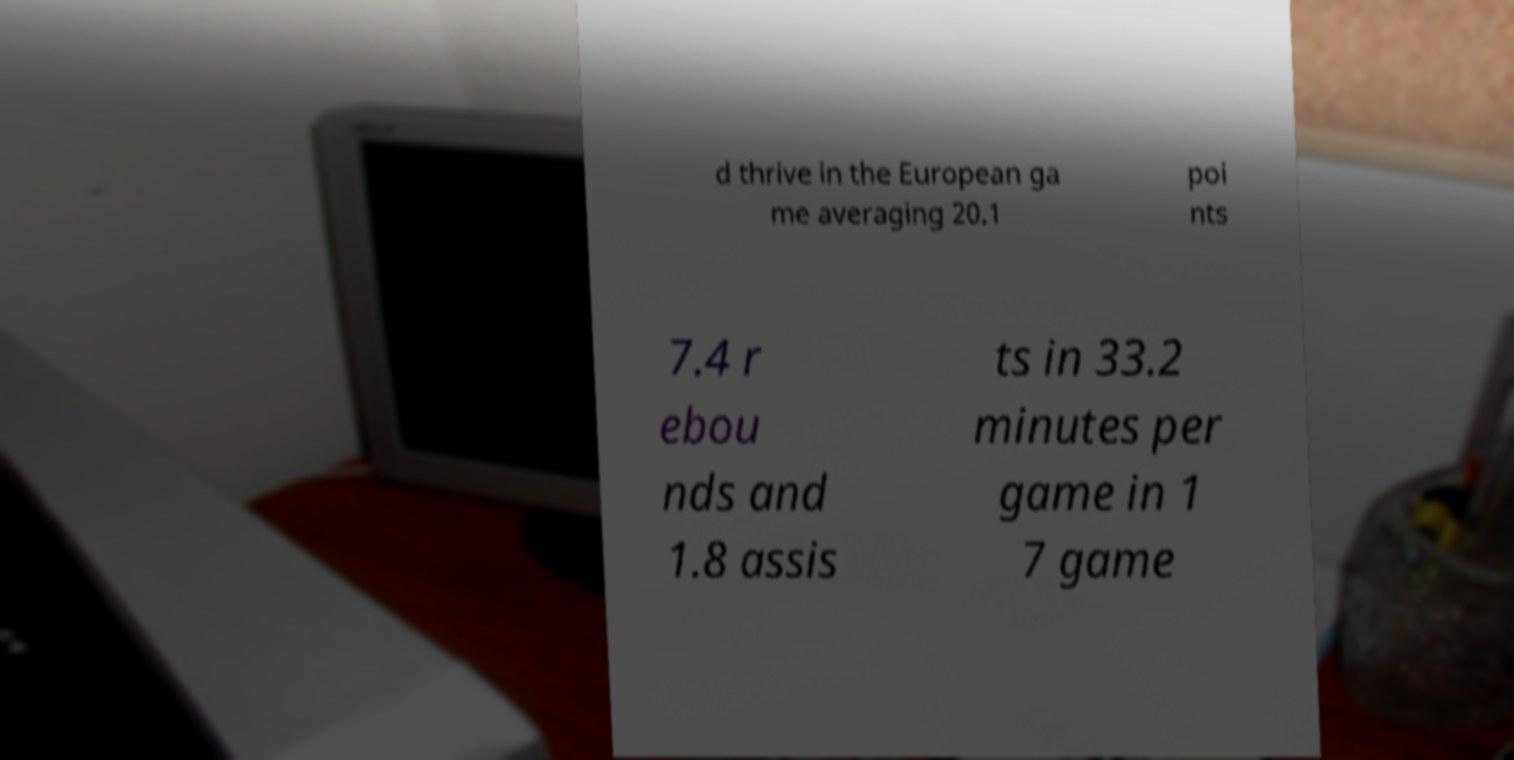What messages or text are displayed in this image? I need them in a readable, typed format. d thrive in the European ga me averaging 20.1 poi nts 7.4 r ebou nds and 1.8 assis ts in 33.2 minutes per game in 1 7 game 